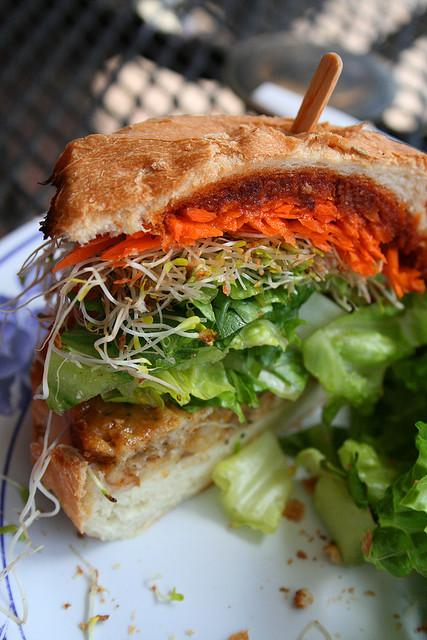This sandwich is probably being eaten in what kind of setting? restaurant 